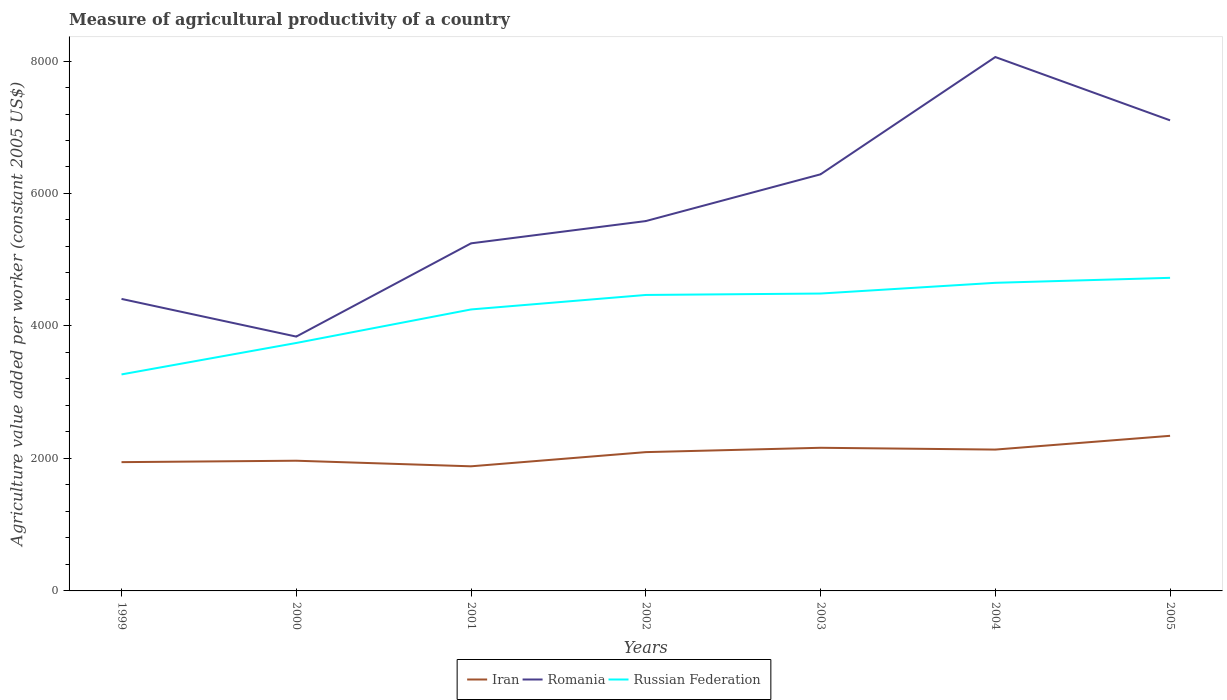How many different coloured lines are there?
Ensure brevity in your answer.  3. Does the line corresponding to Iran intersect with the line corresponding to Russian Federation?
Your answer should be compact. No. Is the number of lines equal to the number of legend labels?
Provide a succinct answer. Yes. Across all years, what is the maximum measure of agricultural productivity in Russian Federation?
Your answer should be very brief. 3268.44. In which year was the measure of agricultural productivity in Russian Federation maximum?
Your response must be concise. 1999. What is the total measure of agricultural productivity in Iran in the graph?
Offer a terse response. -180.69. What is the difference between the highest and the second highest measure of agricultural productivity in Romania?
Offer a very short reply. 4220.34. What is the difference between the highest and the lowest measure of agricultural productivity in Iran?
Keep it short and to the point. 4. How many lines are there?
Ensure brevity in your answer.  3. How many years are there in the graph?
Give a very brief answer. 7. What is the difference between two consecutive major ticks on the Y-axis?
Your answer should be very brief. 2000. Are the values on the major ticks of Y-axis written in scientific E-notation?
Your answer should be compact. No. Does the graph contain any zero values?
Offer a terse response. No. Does the graph contain grids?
Your response must be concise. No. What is the title of the graph?
Provide a succinct answer. Measure of agricultural productivity of a country. What is the label or title of the X-axis?
Offer a terse response. Years. What is the label or title of the Y-axis?
Ensure brevity in your answer.  Agriculture value added per worker (constant 2005 US$). What is the Agriculture value added per worker (constant 2005 US$) in Iran in 1999?
Make the answer very short. 1944.18. What is the Agriculture value added per worker (constant 2005 US$) of Romania in 1999?
Provide a short and direct response. 4408.53. What is the Agriculture value added per worker (constant 2005 US$) in Russian Federation in 1999?
Offer a very short reply. 3268.44. What is the Agriculture value added per worker (constant 2005 US$) in Iran in 2000?
Keep it short and to the point. 1965.61. What is the Agriculture value added per worker (constant 2005 US$) of Romania in 2000?
Keep it short and to the point. 3839.69. What is the Agriculture value added per worker (constant 2005 US$) of Russian Federation in 2000?
Offer a terse response. 3743.25. What is the Agriculture value added per worker (constant 2005 US$) of Iran in 2001?
Offer a terse response. 1881.29. What is the Agriculture value added per worker (constant 2005 US$) of Romania in 2001?
Offer a terse response. 5247.48. What is the Agriculture value added per worker (constant 2005 US$) of Russian Federation in 2001?
Offer a very short reply. 4249.41. What is the Agriculture value added per worker (constant 2005 US$) of Iran in 2002?
Your answer should be compact. 2095.42. What is the Agriculture value added per worker (constant 2005 US$) in Romania in 2002?
Keep it short and to the point. 5583.6. What is the Agriculture value added per worker (constant 2005 US$) in Russian Federation in 2002?
Your answer should be compact. 4468.13. What is the Agriculture value added per worker (constant 2005 US$) of Iran in 2003?
Keep it short and to the point. 2160.97. What is the Agriculture value added per worker (constant 2005 US$) in Romania in 2003?
Your response must be concise. 6289.59. What is the Agriculture value added per worker (constant 2005 US$) of Russian Federation in 2003?
Provide a short and direct response. 4489.58. What is the Agriculture value added per worker (constant 2005 US$) in Iran in 2004?
Provide a short and direct response. 2133.87. What is the Agriculture value added per worker (constant 2005 US$) in Romania in 2004?
Give a very brief answer. 8060.02. What is the Agriculture value added per worker (constant 2005 US$) in Russian Federation in 2004?
Keep it short and to the point. 4651.43. What is the Agriculture value added per worker (constant 2005 US$) in Iran in 2005?
Your answer should be very brief. 2341.66. What is the Agriculture value added per worker (constant 2005 US$) of Romania in 2005?
Provide a short and direct response. 7104.43. What is the Agriculture value added per worker (constant 2005 US$) of Russian Federation in 2005?
Provide a succinct answer. 4726.84. Across all years, what is the maximum Agriculture value added per worker (constant 2005 US$) in Iran?
Your answer should be compact. 2341.66. Across all years, what is the maximum Agriculture value added per worker (constant 2005 US$) in Romania?
Your answer should be very brief. 8060.02. Across all years, what is the maximum Agriculture value added per worker (constant 2005 US$) in Russian Federation?
Offer a terse response. 4726.84. Across all years, what is the minimum Agriculture value added per worker (constant 2005 US$) of Iran?
Give a very brief answer. 1881.29. Across all years, what is the minimum Agriculture value added per worker (constant 2005 US$) of Romania?
Your response must be concise. 3839.69. Across all years, what is the minimum Agriculture value added per worker (constant 2005 US$) in Russian Federation?
Provide a short and direct response. 3268.44. What is the total Agriculture value added per worker (constant 2005 US$) of Iran in the graph?
Give a very brief answer. 1.45e+04. What is the total Agriculture value added per worker (constant 2005 US$) of Romania in the graph?
Make the answer very short. 4.05e+04. What is the total Agriculture value added per worker (constant 2005 US$) in Russian Federation in the graph?
Provide a succinct answer. 2.96e+04. What is the difference between the Agriculture value added per worker (constant 2005 US$) of Iran in 1999 and that in 2000?
Provide a succinct answer. -21.44. What is the difference between the Agriculture value added per worker (constant 2005 US$) in Romania in 1999 and that in 2000?
Provide a short and direct response. 568.84. What is the difference between the Agriculture value added per worker (constant 2005 US$) in Russian Federation in 1999 and that in 2000?
Keep it short and to the point. -474.81. What is the difference between the Agriculture value added per worker (constant 2005 US$) in Iran in 1999 and that in 2001?
Ensure brevity in your answer.  62.88. What is the difference between the Agriculture value added per worker (constant 2005 US$) of Romania in 1999 and that in 2001?
Offer a very short reply. -838.95. What is the difference between the Agriculture value added per worker (constant 2005 US$) in Russian Federation in 1999 and that in 2001?
Your response must be concise. -980.97. What is the difference between the Agriculture value added per worker (constant 2005 US$) of Iran in 1999 and that in 2002?
Your answer should be compact. -151.25. What is the difference between the Agriculture value added per worker (constant 2005 US$) of Romania in 1999 and that in 2002?
Give a very brief answer. -1175.07. What is the difference between the Agriculture value added per worker (constant 2005 US$) in Russian Federation in 1999 and that in 2002?
Ensure brevity in your answer.  -1199.69. What is the difference between the Agriculture value added per worker (constant 2005 US$) of Iran in 1999 and that in 2003?
Make the answer very short. -216.79. What is the difference between the Agriculture value added per worker (constant 2005 US$) of Romania in 1999 and that in 2003?
Provide a short and direct response. -1881.06. What is the difference between the Agriculture value added per worker (constant 2005 US$) in Russian Federation in 1999 and that in 2003?
Your response must be concise. -1221.14. What is the difference between the Agriculture value added per worker (constant 2005 US$) of Iran in 1999 and that in 2004?
Ensure brevity in your answer.  -189.7. What is the difference between the Agriculture value added per worker (constant 2005 US$) of Romania in 1999 and that in 2004?
Provide a short and direct response. -3651.49. What is the difference between the Agriculture value added per worker (constant 2005 US$) in Russian Federation in 1999 and that in 2004?
Your answer should be compact. -1382.99. What is the difference between the Agriculture value added per worker (constant 2005 US$) of Iran in 1999 and that in 2005?
Make the answer very short. -397.48. What is the difference between the Agriculture value added per worker (constant 2005 US$) in Romania in 1999 and that in 2005?
Give a very brief answer. -2695.9. What is the difference between the Agriculture value added per worker (constant 2005 US$) in Russian Federation in 1999 and that in 2005?
Ensure brevity in your answer.  -1458.4. What is the difference between the Agriculture value added per worker (constant 2005 US$) in Iran in 2000 and that in 2001?
Provide a short and direct response. 84.32. What is the difference between the Agriculture value added per worker (constant 2005 US$) of Romania in 2000 and that in 2001?
Provide a short and direct response. -1407.79. What is the difference between the Agriculture value added per worker (constant 2005 US$) of Russian Federation in 2000 and that in 2001?
Your response must be concise. -506.16. What is the difference between the Agriculture value added per worker (constant 2005 US$) in Iran in 2000 and that in 2002?
Your response must be concise. -129.81. What is the difference between the Agriculture value added per worker (constant 2005 US$) in Romania in 2000 and that in 2002?
Provide a succinct answer. -1743.91. What is the difference between the Agriculture value added per worker (constant 2005 US$) of Russian Federation in 2000 and that in 2002?
Your response must be concise. -724.88. What is the difference between the Agriculture value added per worker (constant 2005 US$) in Iran in 2000 and that in 2003?
Provide a succinct answer. -195.35. What is the difference between the Agriculture value added per worker (constant 2005 US$) of Romania in 2000 and that in 2003?
Your answer should be very brief. -2449.9. What is the difference between the Agriculture value added per worker (constant 2005 US$) in Russian Federation in 2000 and that in 2003?
Your answer should be compact. -746.32. What is the difference between the Agriculture value added per worker (constant 2005 US$) in Iran in 2000 and that in 2004?
Provide a short and direct response. -168.26. What is the difference between the Agriculture value added per worker (constant 2005 US$) in Romania in 2000 and that in 2004?
Provide a short and direct response. -4220.34. What is the difference between the Agriculture value added per worker (constant 2005 US$) in Russian Federation in 2000 and that in 2004?
Keep it short and to the point. -908.17. What is the difference between the Agriculture value added per worker (constant 2005 US$) in Iran in 2000 and that in 2005?
Offer a very short reply. -376.05. What is the difference between the Agriculture value added per worker (constant 2005 US$) in Romania in 2000 and that in 2005?
Offer a very short reply. -3264.74. What is the difference between the Agriculture value added per worker (constant 2005 US$) of Russian Federation in 2000 and that in 2005?
Give a very brief answer. -983.59. What is the difference between the Agriculture value added per worker (constant 2005 US$) in Iran in 2001 and that in 2002?
Provide a short and direct response. -214.13. What is the difference between the Agriculture value added per worker (constant 2005 US$) in Romania in 2001 and that in 2002?
Provide a short and direct response. -336.12. What is the difference between the Agriculture value added per worker (constant 2005 US$) of Russian Federation in 2001 and that in 2002?
Provide a succinct answer. -218.72. What is the difference between the Agriculture value added per worker (constant 2005 US$) in Iran in 2001 and that in 2003?
Offer a terse response. -279.67. What is the difference between the Agriculture value added per worker (constant 2005 US$) of Romania in 2001 and that in 2003?
Ensure brevity in your answer.  -1042.11. What is the difference between the Agriculture value added per worker (constant 2005 US$) of Russian Federation in 2001 and that in 2003?
Your answer should be compact. -240.16. What is the difference between the Agriculture value added per worker (constant 2005 US$) in Iran in 2001 and that in 2004?
Your answer should be very brief. -252.58. What is the difference between the Agriculture value added per worker (constant 2005 US$) of Romania in 2001 and that in 2004?
Make the answer very short. -2812.55. What is the difference between the Agriculture value added per worker (constant 2005 US$) in Russian Federation in 2001 and that in 2004?
Provide a short and direct response. -402.01. What is the difference between the Agriculture value added per worker (constant 2005 US$) of Iran in 2001 and that in 2005?
Give a very brief answer. -460.37. What is the difference between the Agriculture value added per worker (constant 2005 US$) in Romania in 2001 and that in 2005?
Keep it short and to the point. -1856.95. What is the difference between the Agriculture value added per worker (constant 2005 US$) of Russian Federation in 2001 and that in 2005?
Your answer should be compact. -477.43. What is the difference between the Agriculture value added per worker (constant 2005 US$) in Iran in 2002 and that in 2003?
Provide a short and direct response. -65.54. What is the difference between the Agriculture value added per worker (constant 2005 US$) of Romania in 2002 and that in 2003?
Provide a short and direct response. -705.99. What is the difference between the Agriculture value added per worker (constant 2005 US$) of Russian Federation in 2002 and that in 2003?
Give a very brief answer. -21.45. What is the difference between the Agriculture value added per worker (constant 2005 US$) in Iran in 2002 and that in 2004?
Provide a short and direct response. -38.45. What is the difference between the Agriculture value added per worker (constant 2005 US$) of Romania in 2002 and that in 2004?
Give a very brief answer. -2476.43. What is the difference between the Agriculture value added per worker (constant 2005 US$) of Russian Federation in 2002 and that in 2004?
Give a very brief answer. -183.3. What is the difference between the Agriculture value added per worker (constant 2005 US$) in Iran in 2002 and that in 2005?
Offer a terse response. -246.24. What is the difference between the Agriculture value added per worker (constant 2005 US$) of Romania in 2002 and that in 2005?
Give a very brief answer. -1520.83. What is the difference between the Agriculture value added per worker (constant 2005 US$) in Russian Federation in 2002 and that in 2005?
Keep it short and to the point. -258.71. What is the difference between the Agriculture value added per worker (constant 2005 US$) of Iran in 2003 and that in 2004?
Provide a short and direct response. 27.09. What is the difference between the Agriculture value added per worker (constant 2005 US$) in Romania in 2003 and that in 2004?
Your response must be concise. -1770.43. What is the difference between the Agriculture value added per worker (constant 2005 US$) in Russian Federation in 2003 and that in 2004?
Your answer should be very brief. -161.85. What is the difference between the Agriculture value added per worker (constant 2005 US$) in Iran in 2003 and that in 2005?
Provide a succinct answer. -180.69. What is the difference between the Agriculture value added per worker (constant 2005 US$) in Romania in 2003 and that in 2005?
Ensure brevity in your answer.  -814.84. What is the difference between the Agriculture value added per worker (constant 2005 US$) in Russian Federation in 2003 and that in 2005?
Your answer should be compact. -237.26. What is the difference between the Agriculture value added per worker (constant 2005 US$) of Iran in 2004 and that in 2005?
Your answer should be compact. -207.79. What is the difference between the Agriculture value added per worker (constant 2005 US$) in Romania in 2004 and that in 2005?
Your answer should be very brief. 955.6. What is the difference between the Agriculture value added per worker (constant 2005 US$) of Russian Federation in 2004 and that in 2005?
Your response must be concise. -75.41. What is the difference between the Agriculture value added per worker (constant 2005 US$) in Iran in 1999 and the Agriculture value added per worker (constant 2005 US$) in Romania in 2000?
Keep it short and to the point. -1895.51. What is the difference between the Agriculture value added per worker (constant 2005 US$) of Iran in 1999 and the Agriculture value added per worker (constant 2005 US$) of Russian Federation in 2000?
Keep it short and to the point. -1799.08. What is the difference between the Agriculture value added per worker (constant 2005 US$) of Romania in 1999 and the Agriculture value added per worker (constant 2005 US$) of Russian Federation in 2000?
Ensure brevity in your answer.  665.28. What is the difference between the Agriculture value added per worker (constant 2005 US$) of Iran in 1999 and the Agriculture value added per worker (constant 2005 US$) of Romania in 2001?
Make the answer very short. -3303.3. What is the difference between the Agriculture value added per worker (constant 2005 US$) of Iran in 1999 and the Agriculture value added per worker (constant 2005 US$) of Russian Federation in 2001?
Make the answer very short. -2305.24. What is the difference between the Agriculture value added per worker (constant 2005 US$) of Romania in 1999 and the Agriculture value added per worker (constant 2005 US$) of Russian Federation in 2001?
Your answer should be compact. 159.12. What is the difference between the Agriculture value added per worker (constant 2005 US$) of Iran in 1999 and the Agriculture value added per worker (constant 2005 US$) of Romania in 2002?
Keep it short and to the point. -3639.42. What is the difference between the Agriculture value added per worker (constant 2005 US$) of Iran in 1999 and the Agriculture value added per worker (constant 2005 US$) of Russian Federation in 2002?
Make the answer very short. -2523.95. What is the difference between the Agriculture value added per worker (constant 2005 US$) in Romania in 1999 and the Agriculture value added per worker (constant 2005 US$) in Russian Federation in 2002?
Provide a short and direct response. -59.6. What is the difference between the Agriculture value added per worker (constant 2005 US$) of Iran in 1999 and the Agriculture value added per worker (constant 2005 US$) of Romania in 2003?
Provide a short and direct response. -4345.42. What is the difference between the Agriculture value added per worker (constant 2005 US$) of Iran in 1999 and the Agriculture value added per worker (constant 2005 US$) of Russian Federation in 2003?
Offer a very short reply. -2545.4. What is the difference between the Agriculture value added per worker (constant 2005 US$) of Romania in 1999 and the Agriculture value added per worker (constant 2005 US$) of Russian Federation in 2003?
Give a very brief answer. -81.05. What is the difference between the Agriculture value added per worker (constant 2005 US$) in Iran in 1999 and the Agriculture value added per worker (constant 2005 US$) in Romania in 2004?
Ensure brevity in your answer.  -6115.85. What is the difference between the Agriculture value added per worker (constant 2005 US$) of Iran in 1999 and the Agriculture value added per worker (constant 2005 US$) of Russian Federation in 2004?
Provide a succinct answer. -2707.25. What is the difference between the Agriculture value added per worker (constant 2005 US$) in Romania in 1999 and the Agriculture value added per worker (constant 2005 US$) in Russian Federation in 2004?
Make the answer very short. -242.9. What is the difference between the Agriculture value added per worker (constant 2005 US$) in Iran in 1999 and the Agriculture value added per worker (constant 2005 US$) in Romania in 2005?
Your answer should be very brief. -5160.25. What is the difference between the Agriculture value added per worker (constant 2005 US$) of Iran in 1999 and the Agriculture value added per worker (constant 2005 US$) of Russian Federation in 2005?
Offer a very short reply. -2782.66. What is the difference between the Agriculture value added per worker (constant 2005 US$) in Romania in 1999 and the Agriculture value added per worker (constant 2005 US$) in Russian Federation in 2005?
Your answer should be very brief. -318.31. What is the difference between the Agriculture value added per worker (constant 2005 US$) of Iran in 2000 and the Agriculture value added per worker (constant 2005 US$) of Romania in 2001?
Your response must be concise. -3281.86. What is the difference between the Agriculture value added per worker (constant 2005 US$) of Iran in 2000 and the Agriculture value added per worker (constant 2005 US$) of Russian Federation in 2001?
Your answer should be very brief. -2283.8. What is the difference between the Agriculture value added per worker (constant 2005 US$) of Romania in 2000 and the Agriculture value added per worker (constant 2005 US$) of Russian Federation in 2001?
Make the answer very short. -409.73. What is the difference between the Agriculture value added per worker (constant 2005 US$) in Iran in 2000 and the Agriculture value added per worker (constant 2005 US$) in Romania in 2002?
Provide a succinct answer. -3617.98. What is the difference between the Agriculture value added per worker (constant 2005 US$) of Iran in 2000 and the Agriculture value added per worker (constant 2005 US$) of Russian Federation in 2002?
Keep it short and to the point. -2502.52. What is the difference between the Agriculture value added per worker (constant 2005 US$) of Romania in 2000 and the Agriculture value added per worker (constant 2005 US$) of Russian Federation in 2002?
Offer a terse response. -628.44. What is the difference between the Agriculture value added per worker (constant 2005 US$) in Iran in 2000 and the Agriculture value added per worker (constant 2005 US$) in Romania in 2003?
Make the answer very short. -4323.98. What is the difference between the Agriculture value added per worker (constant 2005 US$) of Iran in 2000 and the Agriculture value added per worker (constant 2005 US$) of Russian Federation in 2003?
Your answer should be very brief. -2523.96. What is the difference between the Agriculture value added per worker (constant 2005 US$) in Romania in 2000 and the Agriculture value added per worker (constant 2005 US$) in Russian Federation in 2003?
Your answer should be very brief. -649.89. What is the difference between the Agriculture value added per worker (constant 2005 US$) in Iran in 2000 and the Agriculture value added per worker (constant 2005 US$) in Romania in 2004?
Provide a short and direct response. -6094.41. What is the difference between the Agriculture value added per worker (constant 2005 US$) of Iran in 2000 and the Agriculture value added per worker (constant 2005 US$) of Russian Federation in 2004?
Offer a very short reply. -2685.81. What is the difference between the Agriculture value added per worker (constant 2005 US$) in Romania in 2000 and the Agriculture value added per worker (constant 2005 US$) in Russian Federation in 2004?
Your answer should be compact. -811.74. What is the difference between the Agriculture value added per worker (constant 2005 US$) in Iran in 2000 and the Agriculture value added per worker (constant 2005 US$) in Romania in 2005?
Give a very brief answer. -5138.81. What is the difference between the Agriculture value added per worker (constant 2005 US$) in Iran in 2000 and the Agriculture value added per worker (constant 2005 US$) in Russian Federation in 2005?
Provide a succinct answer. -2761.22. What is the difference between the Agriculture value added per worker (constant 2005 US$) in Romania in 2000 and the Agriculture value added per worker (constant 2005 US$) in Russian Federation in 2005?
Provide a succinct answer. -887.15. What is the difference between the Agriculture value added per worker (constant 2005 US$) of Iran in 2001 and the Agriculture value added per worker (constant 2005 US$) of Romania in 2002?
Give a very brief answer. -3702.3. What is the difference between the Agriculture value added per worker (constant 2005 US$) of Iran in 2001 and the Agriculture value added per worker (constant 2005 US$) of Russian Federation in 2002?
Offer a very short reply. -2586.84. What is the difference between the Agriculture value added per worker (constant 2005 US$) of Romania in 2001 and the Agriculture value added per worker (constant 2005 US$) of Russian Federation in 2002?
Keep it short and to the point. 779.35. What is the difference between the Agriculture value added per worker (constant 2005 US$) in Iran in 2001 and the Agriculture value added per worker (constant 2005 US$) in Romania in 2003?
Give a very brief answer. -4408.3. What is the difference between the Agriculture value added per worker (constant 2005 US$) of Iran in 2001 and the Agriculture value added per worker (constant 2005 US$) of Russian Federation in 2003?
Your response must be concise. -2608.28. What is the difference between the Agriculture value added per worker (constant 2005 US$) in Romania in 2001 and the Agriculture value added per worker (constant 2005 US$) in Russian Federation in 2003?
Keep it short and to the point. 757.9. What is the difference between the Agriculture value added per worker (constant 2005 US$) in Iran in 2001 and the Agriculture value added per worker (constant 2005 US$) in Romania in 2004?
Your answer should be very brief. -6178.73. What is the difference between the Agriculture value added per worker (constant 2005 US$) of Iran in 2001 and the Agriculture value added per worker (constant 2005 US$) of Russian Federation in 2004?
Your answer should be very brief. -2770.13. What is the difference between the Agriculture value added per worker (constant 2005 US$) in Romania in 2001 and the Agriculture value added per worker (constant 2005 US$) in Russian Federation in 2004?
Keep it short and to the point. 596.05. What is the difference between the Agriculture value added per worker (constant 2005 US$) of Iran in 2001 and the Agriculture value added per worker (constant 2005 US$) of Romania in 2005?
Keep it short and to the point. -5223.13. What is the difference between the Agriculture value added per worker (constant 2005 US$) in Iran in 2001 and the Agriculture value added per worker (constant 2005 US$) in Russian Federation in 2005?
Your answer should be very brief. -2845.55. What is the difference between the Agriculture value added per worker (constant 2005 US$) in Romania in 2001 and the Agriculture value added per worker (constant 2005 US$) in Russian Federation in 2005?
Your answer should be very brief. 520.64. What is the difference between the Agriculture value added per worker (constant 2005 US$) of Iran in 2002 and the Agriculture value added per worker (constant 2005 US$) of Romania in 2003?
Keep it short and to the point. -4194.17. What is the difference between the Agriculture value added per worker (constant 2005 US$) of Iran in 2002 and the Agriculture value added per worker (constant 2005 US$) of Russian Federation in 2003?
Your answer should be very brief. -2394.15. What is the difference between the Agriculture value added per worker (constant 2005 US$) of Romania in 2002 and the Agriculture value added per worker (constant 2005 US$) of Russian Federation in 2003?
Offer a very short reply. 1094.02. What is the difference between the Agriculture value added per worker (constant 2005 US$) of Iran in 2002 and the Agriculture value added per worker (constant 2005 US$) of Romania in 2004?
Provide a succinct answer. -5964.6. What is the difference between the Agriculture value added per worker (constant 2005 US$) of Iran in 2002 and the Agriculture value added per worker (constant 2005 US$) of Russian Federation in 2004?
Provide a succinct answer. -2556. What is the difference between the Agriculture value added per worker (constant 2005 US$) of Romania in 2002 and the Agriculture value added per worker (constant 2005 US$) of Russian Federation in 2004?
Your answer should be compact. 932.17. What is the difference between the Agriculture value added per worker (constant 2005 US$) in Iran in 2002 and the Agriculture value added per worker (constant 2005 US$) in Romania in 2005?
Offer a terse response. -5009.01. What is the difference between the Agriculture value added per worker (constant 2005 US$) in Iran in 2002 and the Agriculture value added per worker (constant 2005 US$) in Russian Federation in 2005?
Keep it short and to the point. -2631.42. What is the difference between the Agriculture value added per worker (constant 2005 US$) of Romania in 2002 and the Agriculture value added per worker (constant 2005 US$) of Russian Federation in 2005?
Offer a very short reply. 856.76. What is the difference between the Agriculture value added per worker (constant 2005 US$) in Iran in 2003 and the Agriculture value added per worker (constant 2005 US$) in Romania in 2004?
Give a very brief answer. -5899.06. What is the difference between the Agriculture value added per worker (constant 2005 US$) in Iran in 2003 and the Agriculture value added per worker (constant 2005 US$) in Russian Federation in 2004?
Your answer should be compact. -2490.46. What is the difference between the Agriculture value added per worker (constant 2005 US$) in Romania in 2003 and the Agriculture value added per worker (constant 2005 US$) in Russian Federation in 2004?
Make the answer very short. 1638.16. What is the difference between the Agriculture value added per worker (constant 2005 US$) of Iran in 2003 and the Agriculture value added per worker (constant 2005 US$) of Romania in 2005?
Keep it short and to the point. -4943.46. What is the difference between the Agriculture value added per worker (constant 2005 US$) of Iran in 2003 and the Agriculture value added per worker (constant 2005 US$) of Russian Federation in 2005?
Your answer should be compact. -2565.87. What is the difference between the Agriculture value added per worker (constant 2005 US$) of Romania in 2003 and the Agriculture value added per worker (constant 2005 US$) of Russian Federation in 2005?
Your answer should be compact. 1562.75. What is the difference between the Agriculture value added per worker (constant 2005 US$) in Iran in 2004 and the Agriculture value added per worker (constant 2005 US$) in Romania in 2005?
Make the answer very short. -4970.56. What is the difference between the Agriculture value added per worker (constant 2005 US$) in Iran in 2004 and the Agriculture value added per worker (constant 2005 US$) in Russian Federation in 2005?
Your answer should be compact. -2592.97. What is the difference between the Agriculture value added per worker (constant 2005 US$) of Romania in 2004 and the Agriculture value added per worker (constant 2005 US$) of Russian Federation in 2005?
Provide a short and direct response. 3333.18. What is the average Agriculture value added per worker (constant 2005 US$) in Iran per year?
Offer a very short reply. 2074.72. What is the average Agriculture value added per worker (constant 2005 US$) of Romania per year?
Make the answer very short. 5790.48. What is the average Agriculture value added per worker (constant 2005 US$) of Russian Federation per year?
Your answer should be very brief. 4228.15. In the year 1999, what is the difference between the Agriculture value added per worker (constant 2005 US$) in Iran and Agriculture value added per worker (constant 2005 US$) in Romania?
Offer a terse response. -2464.35. In the year 1999, what is the difference between the Agriculture value added per worker (constant 2005 US$) in Iran and Agriculture value added per worker (constant 2005 US$) in Russian Federation?
Make the answer very short. -1324.26. In the year 1999, what is the difference between the Agriculture value added per worker (constant 2005 US$) of Romania and Agriculture value added per worker (constant 2005 US$) of Russian Federation?
Provide a succinct answer. 1140.09. In the year 2000, what is the difference between the Agriculture value added per worker (constant 2005 US$) of Iran and Agriculture value added per worker (constant 2005 US$) of Romania?
Your answer should be very brief. -1874.07. In the year 2000, what is the difference between the Agriculture value added per worker (constant 2005 US$) of Iran and Agriculture value added per worker (constant 2005 US$) of Russian Federation?
Make the answer very short. -1777.64. In the year 2000, what is the difference between the Agriculture value added per worker (constant 2005 US$) of Romania and Agriculture value added per worker (constant 2005 US$) of Russian Federation?
Keep it short and to the point. 96.43. In the year 2001, what is the difference between the Agriculture value added per worker (constant 2005 US$) in Iran and Agriculture value added per worker (constant 2005 US$) in Romania?
Make the answer very short. -3366.19. In the year 2001, what is the difference between the Agriculture value added per worker (constant 2005 US$) of Iran and Agriculture value added per worker (constant 2005 US$) of Russian Federation?
Offer a very short reply. -2368.12. In the year 2001, what is the difference between the Agriculture value added per worker (constant 2005 US$) of Romania and Agriculture value added per worker (constant 2005 US$) of Russian Federation?
Offer a terse response. 998.07. In the year 2002, what is the difference between the Agriculture value added per worker (constant 2005 US$) of Iran and Agriculture value added per worker (constant 2005 US$) of Romania?
Offer a very short reply. -3488.17. In the year 2002, what is the difference between the Agriculture value added per worker (constant 2005 US$) in Iran and Agriculture value added per worker (constant 2005 US$) in Russian Federation?
Keep it short and to the point. -2372.71. In the year 2002, what is the difference between the Agriculture value added per worker (constant 2005 US$) in Romania and Agriculture value added per worker (constant 2005 US$) in Russian Federation?
Your answer should be compact. 1115.47. In the year 2003, what is the difference between the Agriculture value added per worker (constant 2005 US$) of Iran and Agriculture value added per worker (constant 2005 US$) of Romania?
Keep it short and to the point. -4128.62. In the year 2003, what is the difference between the Agriculture value added per worker (constant 2005 US$) in Iran and Agriculture value added per worker (constant 2005 US$) in Russian Federation?
Give a very brief answer. -2328.61. In the year 2003, what is the difference between the Agriculture value added per worker (constant 2005 US$) in Romania and Agriculture value added per worker (constant 2005 US$) in Russian Federation?
Your answer should be compact. 1800.01. In the year 2004, what is the difference between the Agriculture value added per worker (constant 2005 US$) in Iran and Agriculture value added per worker (constant 2005 US$) in Romania?
Offer a very short reply. -5926.15. In the year 2004, what is the difference between the Agriculture value added per worker (constant 2005 US$) of Iran and Agriculture value added per worker (constant 2005 US$) of Russian Federation?
Your answer should be very brief. -2517.55. In the year 2004, what is the difference between the Agriculture value added per worker (constant 2005 US$) in Romania and Agriculture value added per worker (constant 2005 US$) in Russian Federation?
Your answer should be very brief. 3408.6. In the year 2005, what is the difference between the Agriculture value added per worker (constant 2005 US$) in Iran and Agriculture value added per worker (constant 2005 US$) in Romania?
Offer a very short reply. -4762.77. In the year 2005, what is the difference between the Agriculture value added per worker (constant 2005 US$) of Iran and Agriculture value added per worker (constant 2005 US$) of Russian Federation?
Keep it short and to the point. -2385.18. In the year 2005, what is the difference between the Agriculture value added per worker (constant 2005 US$) of Romania and Agriculture value added per worker (constant 2005 US$) of Russian Federation?
Give a very brief answer. 2377.59. What is the ratio of the Agriculture value added per worker (constant 2005 US$) in Iran in 1999 to that in 2000?
Your response must be concise. 0.99. What is the ratio of the Agriculture value added per worker (constant 2005 US$) in Romania in 1999 to that in 2000?
Your response must be concise. 1.15. What is the ratio of the Agriculture value added per worker (constant 2005 US$) in Russian Federation in 1999 to that in 2000?
Provide a short and direct response. 0.87. What is the ratio of the Agriculture value added per worker (constant 2005 US$) in Iran in 1999 to that in 2001?
Your answer should be very brief. 1.03. What is the ratio of the Agriculture value added per worker (constant 2005 US$) in Romania in 1999 to that in 2001?
Provide a succinct answer. 0.84. What is the ratio of the Agriculture value added per worker (constant 2005 US$) of Russian Federation in 1999 to that in 2001?
Give a very brief answer. 0.77. What is the ratio of the Agriculture value added per worker (constant 2005 US$) in Iran in 1999 to that in 2002?
Offer a very short reply. 0.93. What is the ratio of the Agriculture value added per worker (constant 2005 US$) of Romania in 1999 to that in 2002?
Give a very brief answer. 0.79. What is the ratio of the Agriculture value added per worker (constant 2005 US$) of Russian Federation in 1999 to that in 2002?
Keep it short and to the point. 0.73. What is the ratio of the Agriculture value added per worker (constant 2005 US$) in Iran in 1999 to that in 2003?
Keep it short and to the point. 0.9. What is the ratio of the Agriculture value added per worker (constant 2005 US$) in Romania in 1999 to that in 2003?
Provide a succinct answer. 0.7. What is the ratio of the Agriculture value added per worker (constant 2005 US$) of Russian Federation in 1999 to that in 2003?
Give a very brief answer. 0.73. What is the ratio of the Agriculture value added per worker (constant 2005 US$) of Iran in 1999 to that in 2004?
Provide a short and direct response. 0.91. What is the ratio of the Agriculture value added per worker (constant 2005 US$) in Romania in 1999 to that in 2004?
Your response must be concise. 0.55. What is the ratio of the Agriculture value added per worker (constant 2005 US$) of Russian Federation in 1999 to that in 2004?
Keep it short and to the point. 0.7. What is the ratio of the Agriculture value added per worker (constant 2005 US$) of Iran in 1999 to that in 2005?
Keep it short and to the point. 0.83. What is the ratio of the Agriculture value added per worker (constant 2005 US$) of Romania in 1999 to that in 2005?
Offer a very short reply. 0.62. What is the ratio of the Agriculture value added per worker (constant 2005 US$) of Russian Federation in 1999 to that in 2005?
Your response must be concise. 0.69. What is the ratio of the Agriculture value added per worker (constant 2005 US$) in Iran in 2000 to that in 2001?
Keep it short and to the point. 1.04. What is the ratio of the Agriculture value added per worker (constant 2005 US$) in Romania in 2000 to that in 2001?
Make the answer very short. 0.73. What is the ratio of the Agriculture value added per worker (constant 2005 US$) of Russian Federation in 2000 to that in 2001?
Offer a very short reply. 0.88. What is the ratio of the Agriculture value added per worker (constant 2005 US$) in Iran in 2000 to that in 2002?
Provide a succinct answer. 0.94. What is the ratio of the Agriculture value added per worker (constant 2005 US$) in Romania in 2000 to that in 2002?
Provide a succinct answer. 0.69. What is the ratio of the Agriculture value added per worker (constant 2005 US$) of Russian Federation in 2000 to that in 2002?
Keep it short and to the point. 0.84. What is the ratio of the Agriculture value added per worker (constant 2005 US$) in Iran in 2000 to that in 2003?
Ensure brevity in your answer.  0.91. What is the ratio of the Agriculture value added per worker (constant 2005 US$) in Romania in 2000 to that in 2003?
Offer a terse response. 0.61. What is the ratio of the Agriculture value added per worker (constant 2005 US$) of Russian Federation in 2000 to that in 2003?
Offer a terse response. 0.83. What is the ratio of the Agriculture value added per worker (constant 2005 US$) of Iran in 2000 to that in 2004?
Offer a terse response. 0.92. What is the ratio of the Agriculture value added per worker (constant 2005 US$) in Romania in 2000 to that in 2004?
Provide a short and direct response. 0.48. What is the ratio of the Agriculture value added per worker (constant 2005 US$) of Russian Federation in 2000 to that in 2004?
Provide a succinct answer. 0.8. What is the ratio of the Agriculture value added per worker (constant 2005 US$) of Iran in 2000 to that in 2005?
Make the answer very short. 0.84. What is the ratio of the Agriculture value added per worker (constant 2005 US$) of Romania in 2000 to that in 2005?
Provide a short and direct response. 0.54. What is the ratio of the Agriculture value added per worker (constant 2005 US$) in Russian Federation in 2000 to that in 2005?
Make the answer very short. 0.79. What is the ratio of the Agriculture value added per worker (constant 2005 US$) in Iran in 2001 to that in 2002?
Your answer should be compact. 0.9. What is the ratio of the Agriculture value added per worker (constant 2005 US$) in Romania in 2001 to that in 2002?
Offer a very short reply. 0.94. What is the ratio of the Agriculture value added per worker (constant 2005 US$) of Russian Federation in 2001 to that in 2002?
Your response must be concise. 0.95. What is the ratio of the Agriculture value added per worker (constant 2005 US$) in Iran in 2001 to that in 2003?
Your answer should be very brief. 0.87. What is the ratio of the Agriculture value added per worker (constant 2005 US$) of Romania in 2001 to that in 2003?
Provide a short and direct response. 0.83. What is the ratio of the Agriculture value added per worker (constant 2005 US$) in Russian Federation in 2001 to that in 2003?
Your answer should be compact. 0.95. What is the ratio of the Agriculture value added per worker (constant 2005 US$) of Iran in 2001 to that in 2004?
Your response must be concise. 0.88. What is the ratio of the Agriculture value added per worker (constant 2005 US$) of Romania in 2001 to that in 2004?
Keep it short and to the point. 0.65. What is the ratio of the Agriculture value added per worker (constant 2005 US$) of Russian Federation in 2001 to that in 2004?
Provide a short and direct response. 0.91. What is the ratio of the Agriculture value added per worker (constant 2005 US$) in Iran in 2001 to that in 2005?
Keep it short and to the point. 0.8. What is the ratio of the Agriculture value added per worker (constant 2005 US$) of Romania in 2001 to that in 2005?
Keep it short and to the point. 0.74. What is the ratio of the Agriculture value added per worker (constant 2005 US$) of Russian Federation in 2001 to that in 2005?
Give a very brief answer. 0.9. What is the ratio of the Agriculture value added per worker (constant 2005 US$) of Iran in 2002 to that in 2003?
Offer a terse response. 0.97. What is the ratio of the Agriculture value added per worker (constant 2005 US$) of Romania in 2002 to that in 2003?
Make the answer very short. 0.89. What is the ratio of the Agriculture value added per worker (constant 2005 US$) of Iran in 2002 to that in 2004?
Offer a very short reply. 0.98. What is the ratio of the Agriculture value added per worker (constant 2005 US$) in Romania in 2002 to that in 2004?
Provide a succinct answer. 0.69. What is the ratio of the Agriculture value added per worker (constant 2005 US$) in Russian Federation in 2002 to that in 2004?
Offer a terse response. 0.96. What is the ratio of the Agriculture value added per worker (constant 2005 US$) of Iran in 2002 to that in 2005?
Offer a terse response. 0.89. What is the ratio of the Agriculture value added per worker (constant 2005 US$) in Romania in 2002 to that in 2005?
Your answer should be very brief. 0.79. What is the ratio of the Agriculture value added per worker (constant 2005 US$) of Russian Federation in 2002 to that in 2005?
Provide a short and direct response. 0.95. What is the ratio of the Agriculture value added per worker (constant 2005 US$) in Iran in 2003 to that in 2004?
Make the answer very short. 1.01. What is the ratio of the Agriculture value added per worker (constant 2005 US$) in Romania in 2003 to that in 2004?
Offer a very short reply. 0.78. What is the ratio of the Agriculture value added per worker (constant 2005 US$) of Russian Federation in 2003 to that in 2004?
Your answer should be very brief. 0.97. What is the ratio of the Agriculture value added per worker (constant 2005 US$) in Iran in 2003 to that in 2005?
Offer a very short reply. 0.92. What is the ratio of the Agriculture value added per worker (constant 2005 US$) of Romania in 2003 to that in 2005?
Ensure brevity in your answer.  0.89. What is the ratio of the Agriculture value added per worker (constant 2005 US$) of Russian Federation in 2003 to that in 2005?
Your answer should be very brief. 0.95. What is the ratio of the Agriculture value added per worker (constant 2005 US$) in Iran in 2004 to that in 2005?
Your answer should be very brief. 0.91. What is the ratio of the Agriculture value added per worker (constant 2005 US$) of Romania in 2004 to that in 2005?
Your answer should be compact. 1.13. What is the ratio of the Agriculture value added per worker (constant 2005 US$) of Russian Federation in 2004 to that in 2005?
Provide a short and direct response. 0.98. What is the difference between the highest and the second highest Agriculture value added per worker (constant 2005 US$) of Iran?
Offer a terse response. 180.69. What is the difference between the highest and the second highest Agriculture value added per worker (constant 2005 US$) in Romania?
Give a very brief answer. 955.6. What is the difference between the highest and the second highest Agriculture value added per worker (constant 2005 US$) of Russian Federation?
Ensure brevity in your answer.  75.41. What is the difference between the highest and the lowest Agriculture value added per worker (constant 2005 US$) of Iran?
Provide a short and direct response. 460.37. What is the difference between the highest and the lowest Agriculture value added per worker (constant 2005 US$) of Romania?
Give a very brief answer. 4220.34. What is the difference between the highest and the lowest Agriculture value added per worker (constant 2005 US$) of Russian Federation?
Your answer should be compact. 1458.4. 